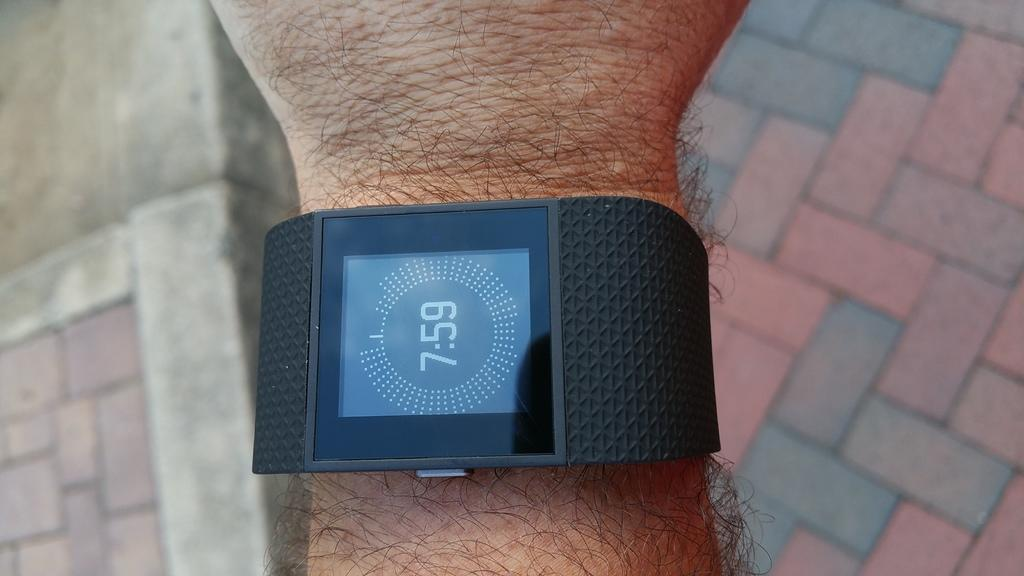<image>
Share a concise interpretation of the image provided. A person is wearing a smart watch that shows the time is 7:59. 